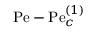<formula> <loc_0><loc_0><loc_500><loc_500>P e - P e _ { c } ^ { ( 1 ) }</formula> 